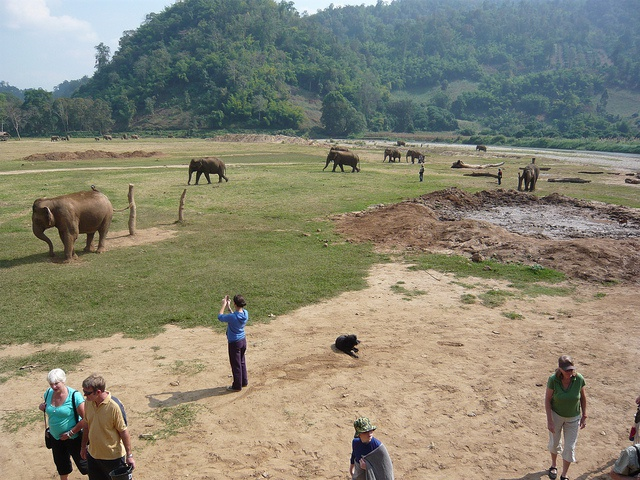Describe the objects in this image and their specific colors. I can see people in lavender, brown, black, gray, and maroon tones, elephant in lavender, black, and gray tones, people in lavender, black, gray, maroon, and darkgray tones, people in lavender, black, teal, maroon, and gray tones, and people in lavender, black, gray, darkgray, and navy tones in this image. 